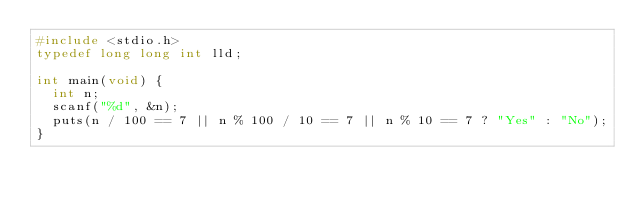Convert code to text. <code><loc_0><loc_0><loc_500><loc_500><_C_>#include <stdio.h>
typedef long long int lld;

int main(void) {
  int n;
  scanf("%d", &n);
  puts(n / 100 == 7 || n % 100 / 10 == 7 || n % 10 == 7 ? "Yes" : "No");
}</code> 